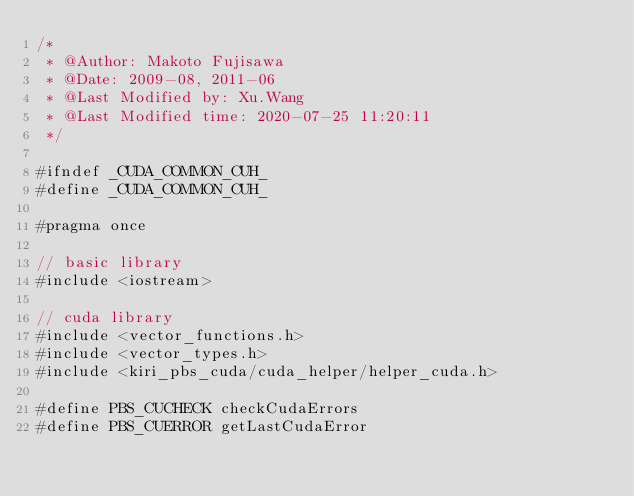Convert code to text. <code><loc_0><loc_0><loc_500><loc_500><_Cuda_>/*
 * @Author: Makoto Fujisawa
 * @Date: 2009-08, 2011-06
 * @Last Modified by: Xu.Wang
 * @Last Modified time: 2020-07-25 11:20:11
 */

#ifndef _CUDA_COMMON_CUH_
#define _CUDA_COMMON_CUH_

#pragma once

// basic library
#include <iostream>

// cuda library
#include <vector_functions.h>
#include <vector_types.h>
#include <kiri_pbs_cuda/cuda_helper/helper_cuda.h>

#define PBS_CUCHECK checkCudaErrors
#define PBS_CUERROR getLastCudaError
</code> 